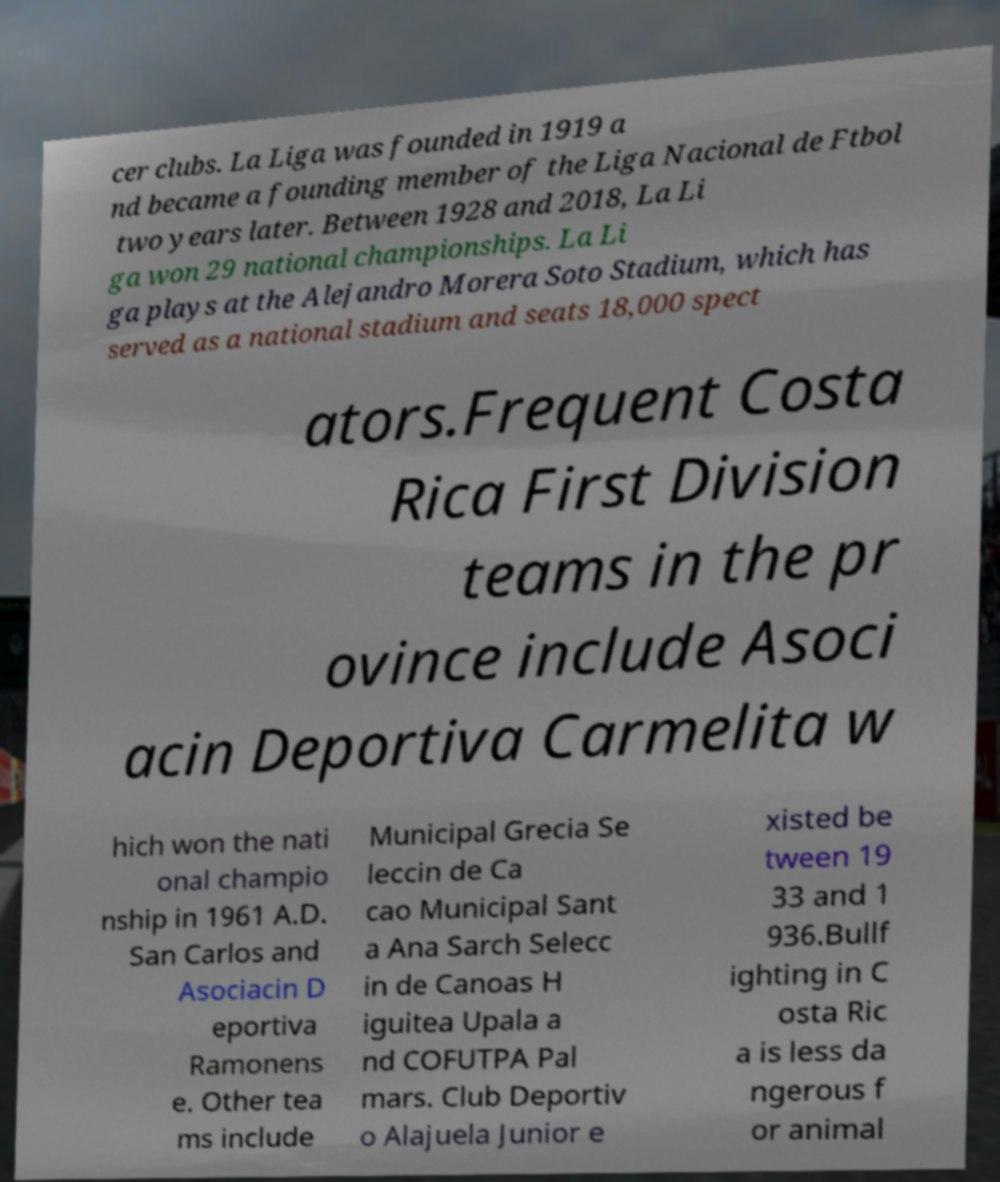For documentation purposes, I need the text within this image transcribed. Could you provide that? cer clubs. La Liga was founded in 1919 a nd became a founding member of the Liga Nacional de Ftbol two years later. Between 1928 and 2018, La Li ga won 29 national championships. La Li ga plays at the Alejandro Morera Soto Stadium, which has served as a national stadium and seats 18,000 spect ators.Frequent Costa Rica First Division teams in the pr ovince include Asoci acin Deportiva Carmelita w hich won the nati onal champio nship in 1961 A.D. San Carlos and Asociacin D eportiva Ramonens e. Other tea ms include Municipal Grecia Se leccin de Ca cao Municipal Sant a Ana Sarch Selecc in de Canoas H iguitea Upala a nd COFUTPA Pal mars. Club Deportiv o Alajuela Junior e xisted be tween 19 33 and 1 936.Bullf ighting in C osta Ric a is less da ngerous f or animal 